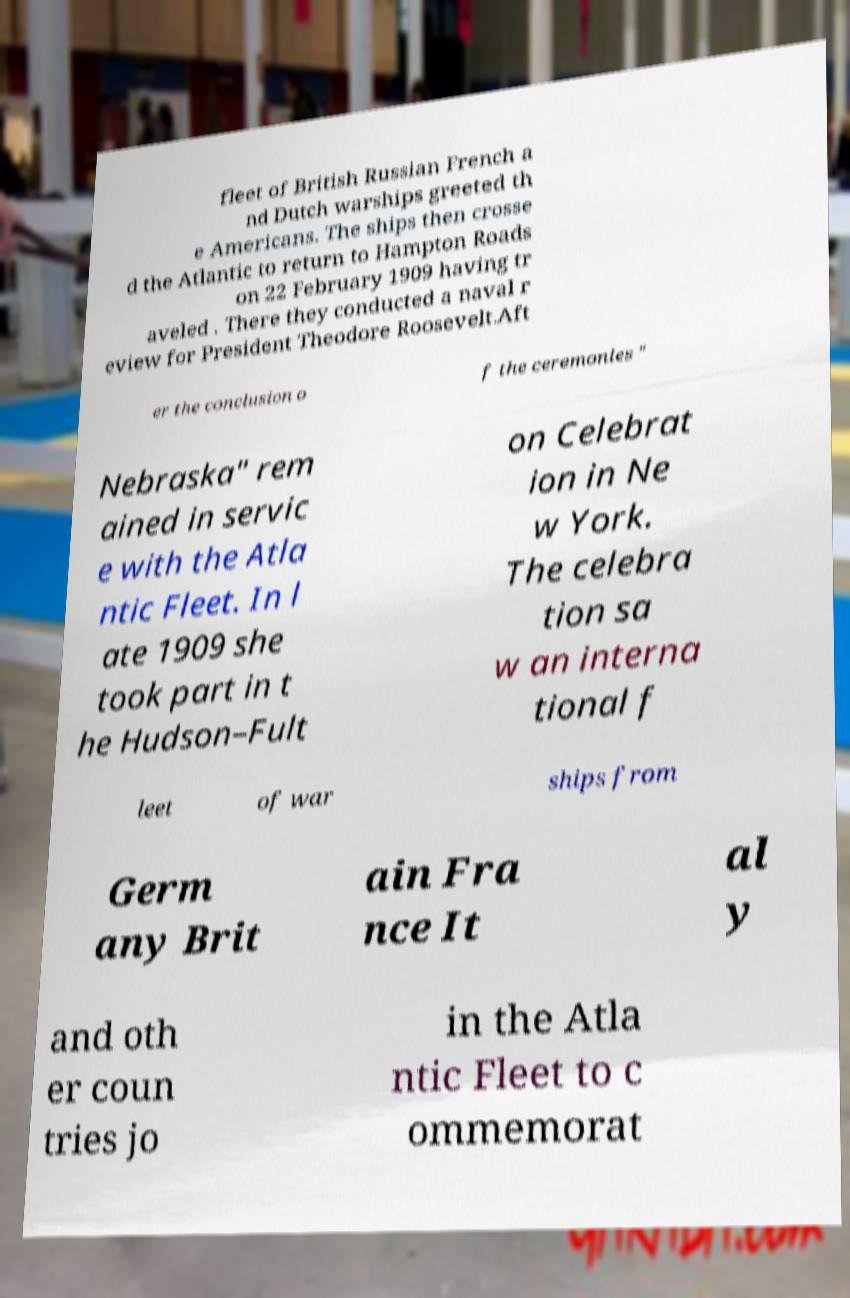Could you assist in decoding the text presented in this image and type it out clearly? fleet of British Russian French a nd Dutch warships greeted th e Americans. The ships then crosse d the Atlantic to return to Hampton Roads on 22 February 1909 having tr aveled . There they conducted a naval r eview for President Theodore Roosevelt.Aft er the conclusion o f the ceremonies " Nebraska" rem ained in servic e with the Atla ntic Fleet. In l ate 1909 she took part in t he Hudson–Fult on Celebrat ion in Ne w York. The celebra tion sa w an interna tional f leet of war ships from Germ any Brit ain Fra nce It al y and oth er coun tries jo in the Atla ntic Fleet to c ommemorat 